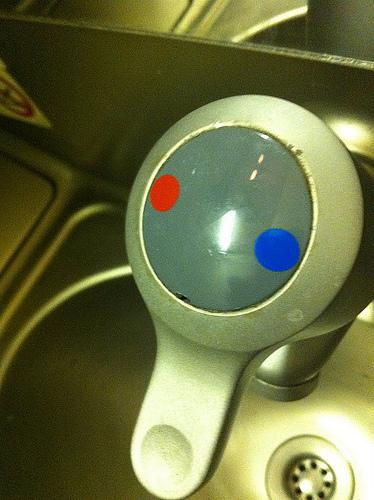Question: how many knobs are pictured?
Choices:
A. 7.
B. 1.
C. 8.
D. 9.
Answer with the letter. Answer: B Question: who is in the photo?
Choices:
A. No one.
B. Soccer team.
C. Army.
D. Teenagers.
Answer with the letter. Answer: A Question: why are there colors on the faucet?
Choices:
A. To indicate hot and cold.
B. For decoration.
C. To show purpose.
D. To make it more visible.
Answer with the letter. Answer: A Question: when is the faucet on?
Choices:
A. When the handle is torned.
B. When the knob is pushed up.
C. When something is held under it.
D. When the pedal is pushed.
Answer with the letter. Answer: B Question: what color is the knob?
Choices:
A. Red.
B. Silver.
C. Orange.
D. Green.
Answer with the letter. Answer: B Question: where is the drain?
Choices:
A. In the bathtub.
B. In the sink.
C. The shower floor.
D. Under the wall.
Answer with the letter. Answer: B 